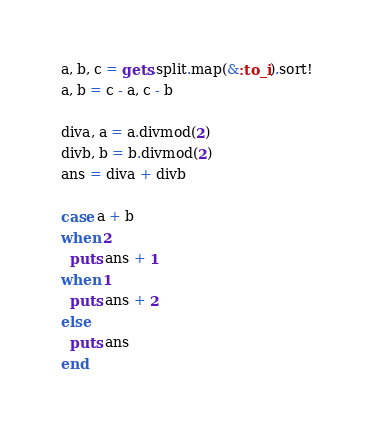Convert code to text. <code><loc_0><loc_0><loc_500><loc_500><_Ruby_>a, b, c = gets.split.map(&:to_i).sort!
a, b = c - a, c - b

diva, a = a.divmod(2)
divb, b = b.divmod(2)
ans = diva + divb

case a + b
when 2
  puts ans + 1
when 1
  puts ans + 2
else
  puts ans
end
</code> 